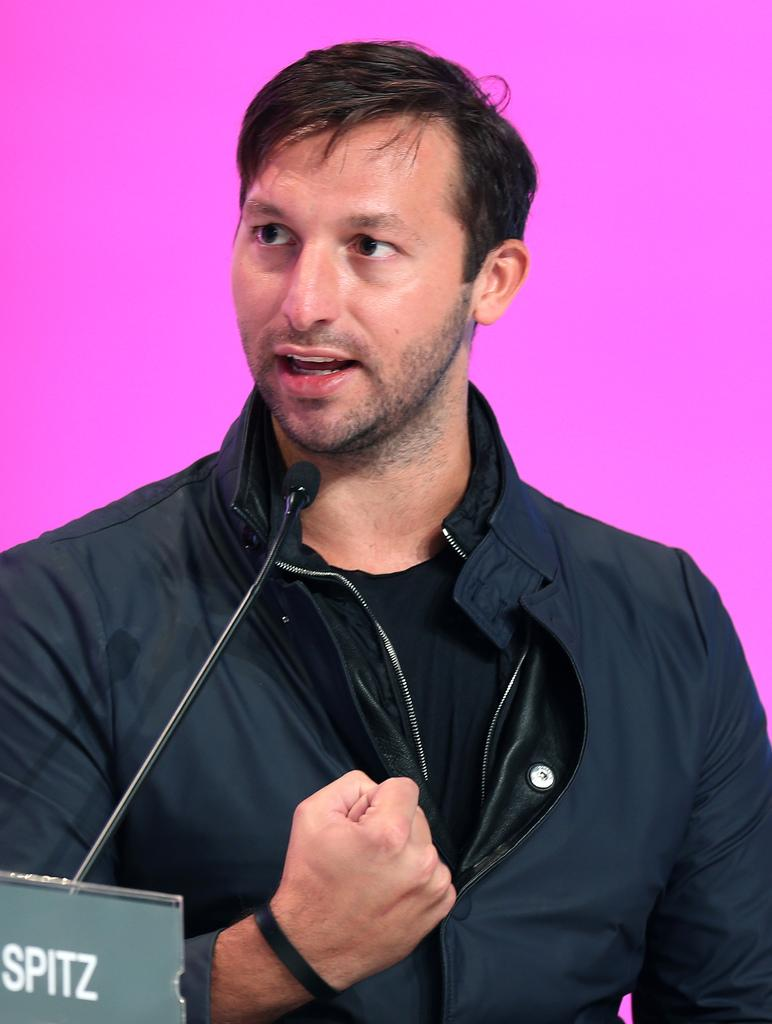Who is the person in the image? There is a man in the image. What is the man wearing? The man is wearing a black jacket. What object is in front of the man? There is a microphone in front of the man. What is the man standing in front of? There is a board in front of the man. What color is the background behind the man? The background behind the man is pink. What type of coal is being used to grow the corn in the image? There is no coal or corn present in the image. How does the drain affect the man's performance in the image? There is no drain present in the image, so it cannot affect the man's performance. 